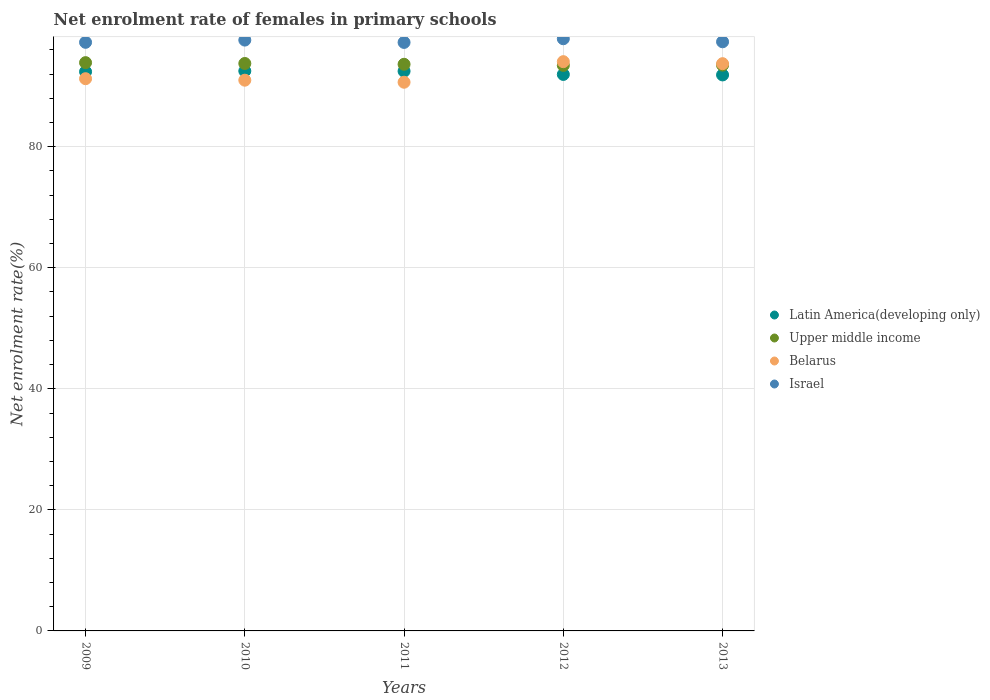How many different coloured dotlines are there?
Your response must be concise. 4. Is the number of dotlines equal to the number of legend labels?
Your answer should be compact. Yes. What is the net enrolment rate of females in primary schools in Israel in 2012?
Give a very brief answer. 97.83. Across all years, what is the maximum net enrolment rate of females in primary schools in Latin America(developing only)?
Your answer should be compact. 92.5. Across all years, what is the minimum net enrolment rate of females in primary schools in Latin America(developing only)?
Give a very brief answer. 91.85. In which year was the net enrolment rate of females in primary schools in Israel minimum?
Offer a terse response. 2011. What is the total net enrolment rate of females in primary schools in Israel in the graph?
Your answer should be very brief. 487.22. What is the difference between the net enrolment rate of females in primary schools in Upper middle income in 2012 and that in 2013?
Your response must be concise. -0.04. What is the difference between the net enrolment rate of females in primary schools in Upper middle income in 2011 and the net enrolment rate of females in primary schools in Israel in 2012?
Your answer should be very brief. -4.22. What is the average net enrolment rate of females in primary schools in Israel per year?
Provide a succinct answer. 97.44. In the year 2011, what is the difference between the net enrolment rate of females in primary schools in Upper middle income and net enrolment rate of females in primary schools in Israel?
Your response must be concise. -3.61. In how many years, is the net enrolment rate of females in primary schools in Upper middle income greater than 68 %?
Your response must be concise. 5. What is the ratio of the net enrolment rate of females in primary schools in Israel in 2012 to that in 2013?
Make the answer very short. 1.01. Is the difference between the net enrolment rate of females in primary schools in Upper middle income in 2009 and 2011 greater than the difference between the net enrolment rate of females in primary schools in Israel in 2009 and 2011?
Keep it short and to the point. Yes. What is the difference between the highest and the second highest net enrolment rate of females in primary schools in Belarus?
Give a very brief answer. 0.33. What is the difference between the highest and the lowest net enrolment rate of females in primary schools in Latin America(developing only)?
Provide a succinct answer. 0.65. In how many years, is the net enrolment rate of females in primary schools in Israel greater than the average net enrolment rate of females in primary schools in Israel taken over all years?
Ensure brevity in your answer.  2. Is it the case that in every year, the sum of the net enrolment rate of females in primary schools in Israel and net enrolment rate of females in primary schools in Belarus  is greater than the sum of net enrolment rate of females in primary schools in Latin America(developing only) and net enrolment rate of females in primary schools in Upper middle income?
Keep it short and to the point. No. Does the net enrolment rate of females in primary schools in Upper middle income monotonically increase over the years?
Keep it short and to the point. No. Is the net enrolment rate of females in primary schools in Upper middle income strictly greater than the net enrolment rate of females in primary schools in Israel over the years?
Ensure brevity in your answer.  No. How many dotlines are there?
Provide a short and direct response. 4. How many years are there in the graph?
Your answer should be very brief. 5. Are the values on the major ticks of Y-axis written in scientific E-notation?
Your answer should be very brief. No. Does the graph contain any zero values?
Ensure brevity in your answer.  No. Where does the legend appear in the graph?
Offer a terse response. Center right. How many legend labels are there?
Give a very brief answer. 4. What is the title of the graph?
Keep it short and to the point. Net enrolment rate of females in primary schools. Does "Latin America(developing only)" appear as one of the legend labels in the graph?
Your response must be concise. Yes. What is the label or title of the X-axis?
Provide a succinct answer. Years. What is the label or title of the Y-axis?
Offer a very short reply. Net enrolment rate(%). What is the Net enrolment rate(%) of Latin America(developing only) in 2009?
Your answer should be compact. 92.39. What is the Net enrolment rate(%) in Upper middle income in 2009?
Make the answer very short. 93.88. What is the Net enrolment rate(%) of Belarus in 2009?
Your response must be concise. 91.23. What is the Net enrolment rate(%) of Israel in 2009?
Provide a short and direct response. 97.24. What is the Net enrolment rate(%) of Latin America(developing only) in 2010?
Your response must be concise. 92.5. What is the Net enrolment rate(%) of Upper middle income in 2010?
Keep it short and to the point. 93.74. What is the Net enrolment rate(%) of Belarus in 2010?
Offer a terse response. 90.98. What is the Net enrolment rate(%) of Israel in 2010?
Your answer should be very brief. 97.61. What is the Net enrolment rate(%) in Latin America(developing only) in 2011?
Ensure brevity in your answer.  92.47. What is the Net enrolment rate(%) of Upper middle income in 2011?
Your response must be concise. 93.61. What is the Net enrolment rate(%) of Belarus in 2011?
Provide a short and direct response. 90.65. What is the Net enrolment rate(%) in Israel in 2011?
Your answer should be very brief. 97.22. What is the Net enrolment rate(%) in Latin America(developing only) in 2012?
Make the answer very short. 91.93. What is the Net enrolment rate(%) in Upper middle income in 2012?
Your answer should be very brief. 93.43. What is the Net enrolment rate(%) in Belarus in 2012?
Your response must be concise. 94.04. What is the Net enrolment rate(%) in Israel in 2012?
Make the answer very short. 97.83. What is the Net enrolment rate(%) in Latin America(developing only) in 2013?
Offer a terse response. 91.85. What is the Net enrolment rate(%) of Upper middle income in 2013?
Keep it short and to the point. 93.47. What is the Net enrolment rate(%) in Belarus in 2013?
Keep it short and to the point. 93.71. What is the Net enrolment rate(%) of Israel in 2013?
Provide a succinct answer. 97.33. Across all years, what is the maximum Net enrolment rate(%) of Latin America(developing only)?
Make the answer very short. 92.5. Across all years, what is the maximum Net enrolment rate(%) of Upper middle income?
Give a very brief answer. 93.88. Across all years, what is the maximum Net enrolment rate(%) in Belarus?
Offer a terse response. 94.04. Across all years, what is the maximum Net enrolment rate(%) in Israel?
Offer a very short reply. 97.83. Across all years, what is the minimum Net enrolment rate(%) of Latin America(developing only)?
Keep it short and to the point. 91.85. Across all years, what is the minimum Net enrolment rate(%) in Upper middle income?
Offer a very short reply. 93.43. Across all years, what is the minimum Net enrolment rate(%) of Belarus?
Give a very brief answer. 90.65. Across all years, what is the minimum Net enrolment rate(%) of Israel?
Provide a short and direct response. 97.22. What is the total Net enrolment rate(%) of Latin America(developing only) in the graph?
Offer a very short reply. 461.15. What is the total Net enrolment rate(%) in Upper middle income in the graph?
Your answer should be compact. 468.14. What is the total Net enrolment rate(%) of Belarus in the graph?
Your answer should be compact. 460.61. What is the total Net enrolment rate(%) in Israel in the graph?
Provide a short and direct response. 487.22. What is the difference between the Net enrolment rate(%) of Latin America(developing only) in 2009 and that in 2010?
Keep it short and to the point. -0.12. What is the difference between the Net enrolment rate(%) of Upper middle income in 2009 and that in 2010?
Keep it short and to the point. 0.14. What is the difference between the Net enrolment rate(%) in Belarus in 2009 and that in 2010?
Offer a very short reply. 0.25. What is the difference between the Net enrolment rate(%) of Israel in 2009 and that in 2010?
Give a very brief answer. -0.37. What is the difference between the Net enrolment rate(%) in Latin America(developing only) in 2009 and that in 2011?
Offer a very short reply. -0.09. What is the difference between the Net enrolment rate(%) in Upper middle income in 2009 and that in 2011?
Your answer should be very brief. 0.27. What is the difference between the Net enrolment rate(%) in Belarus in 2009 and that in 2011?
Ensure brevity in your answer.  0.58. What is the difference between the Net enrolment rate(%) of Israel in 2009 and that in 2011?
Offer a terse response. 0.02. What is the difference between the Net enrolment rate(%) in Latin America(developing only) in 2009 and that in 2012?
Make the answer very short. 0.45. What is the difference between the Net enrolment rate(%) of Upper middle income in 2009 and that in 2012?
Keep it short and to the point. 0.45. What is the difference between the Net enrolment rate(%) in Belarus in 2009 and that in 2012?
Your answer should be compact. -2.81. What is the difference between the Net enrolment rate(%) of Israel in 2009 and that in 2012?
Your answer should be very brief. -0.59. What is the difference between the Net enrolment rate(%) of Latin America(developing only) in 2009 and that in 2013?
Give a very brief answer. 0.53. What is the difference between the Net enrolment rate(%) in Upper middle income in 2009 and that in 2013?
Your answer should be compact. 0.41. What is the difference between the Net enrolment rate(%) of Belarus in 2009 and that in 2013?
Your answer should be very brief. -2.48. What is the difference between the Net enrolment rate(%) of Israel in 2009 and that in 2013?
Your answer should be compact. -0.09. What is the difference between the Net enrolment rate(%) in Latin America(developing only) in 2010 and that in 2011?
Ensure brevity in your answer.  0.03. What is the difference between the Net enrolment rate(%) in Upper middle income in 2010 and that in 2011?
Offer a very short reply. 0.13. What is the difference between the Net enrolment rate(%) in Belarus in 2010 and that in 2011?
Make the answer very short. 0.34. What is the difference between the Net enrolment rate(%) in Israel in 2010 and that in 2011?
Offer a very short reply. 0.39. What is the difference between the Net enrolment rate(%) of Latin America(developing only) in 2010 and that in 2012?
Give a very brief answer. 0.57. What is the difference between the Net enrolment rate(%) of Upper middle income in 2010 and that in 2012?
Offer a very short reply. 0.31. What is the difference between the Net enrolment rate(%) of Belarus in 2010 and that in 2012?
Make the answer very short. -3.06. What is the difference between the Net enrolment rate(%) in Israel in 2010 and that in 2012?
Provide a short and direct response. -0.22. What is the difference between the Net enrolment rate(%) of Latin America(developing only) in 2010 and that in 2013?
Make the answer very short. 0.65. What is the difference between the Net enrolment rate(%) of Upper middle income in 2010 and that in 2013?
Your answer should be compact. 0.27. What is the difference between the Net enrolment rate(%) in Belarus in 2010 and that in 2013?
Offer a very short reply. -2.73. What is the difference between the Net enrolment rate(%) in Israel in 2010 and that in 2013?
Make the answer very short. 0.28. What is the difference between the Net enrolment rate(%) of Latin America(developing only) in 2011 and that in 2012?
Your answer should be very brief. 0.54. What is the difference between the Net enrolment rate(%) of Upper middle income in 2011 and that in 2012?
Keep it short and to the point. 0.18. What is the difference between the Net enrolment rate(%) of Belarus in 2011 and that in 2012?
Keep it short and to the point. -3.4. What is the difference between the Net enrolment rate(%) in Israel in 2011 and that in 2012?
Give a very brief answer. -0.61. What is the difference between the Net enrolment rate(%) in Latin America(developing only) in 2011 and that in 2013?
Ensure brevity in your answer.  0.62. What is the difference between the Net enrolment rate(%) of Upper middle income in 2011 and that in 2013?
Ensure brevity in your answer.  0.14. What is the difference between the Net enrolment rate(%) in Belarus in 2011 and that in 2013?
Make the answer very short. -3.07. What is the difference between the Net enrolment rate(%) of Israel in 2011 and that in 2013?
Provide a short and direct response. -0.11. What is the difference between the Net enrolment rate(%) of Latin America(developing only) in 2012 and that in 2013?
Your response must be concise. 0.08. What is the difference between the Net enrolment rate(%) of Upper middle income in 2012 and that in 2013?
Keep it short and to the point. -0.04. What is the difference between the Net enrolment rate(%) of Belarus in 2012 and that in 2013?
Keep it short and to the point. 0.33. What is the difference between the Net enrolment rate(%) of Israel in 2012 and that in 2013?
Make the answer very short. 0.5. What is the difference between the Net enrolment rate(%) in Latin America(developing only) in 2009 and the Net enrolment rate(%) in Upper middle income in 2010?
Ensure brevity in your answer.  -1.36. What is the difference between the Net enrolment rate(%) in Latin America(developing only) in 2009 and the Net enrolment rate(%) in Belarus in 2010?
Ensure brevity in your answer.  1.4. What is the difference between the Net enrolment rate(%) in Latin America(developing only) in 2009 and the Net enrolment rate(%) in Israel in 2010?
Your response must be concise. -5.22. What is the difference between the Net enrolment rate(%) in Upper middle income in 2009 and the Net enrolment rate(%) in Belarus in 2010?
Offer a very short reply. 2.9. What is the difference between the Net enrolment rate(%) in Upper middle income in 2009 and the Net enrolment rate(%) in Israel in 2010?
Offer a very short reply. -3.73. What is the difference between the Net enrolment rate(%) of Belarus in 2009 and the Net enrolment rate(%) of Israel in 2010?
Provide a short and direct response. -6.38. What is the difference between the Net enrolment rate(%) in Latin America(developing only) in 2009 and the Net enrolment rate(%) in Upper middle income in 2011?
Make the answer very short. -1.22. What is the difference between the Net enrolment rate(%) of Latin America(developing only) in 2009 and the Net enrolment rate(%) of Belarus in 2011?
Your response must be concise. 1.74. What is the difference between the Net enrolment rate(%) in Latin America(developing only) in 2009 and the Net enrolment rate(%) in Israel in 2011?
Provide a short and direct response. -4.84. What is the difference between the Net enrolment rate(%) of Upper middle income in 2009 and the Net enrolment rate(%) of Belarus in 2011?
Make the answer very short. 3.24. What is the difference between the Net enrolment rate(%) of Upper middle income in 2009 and the Net enrolment rate(%) of Israel in 2011?
Your response must be concise. -3.34. What is the difference between the Net enrolment rate(%) of Belarus in 2009 and the Net enrolment rate(%) of Israel in 2011?
Give a very brief answer. -5.99. What is the difference between the Net enrolment rate(%) in Latin America(developing only) in 2009 and the Net enrolment rate(%) in Upper middle income in 2012?
Give a very brief answer. -1.05. What is the difference between the Net enrolment rate(%) in Latin America(developing only) in 2009 and the Net enrolment rate(%) in Belarus in 2012?
Ensure brevity in your answer.  -1.66. What is the difference between the Net enrolment rate(%) in Latin America(developing only) in 2009 and the Net enrolment rate(%) in Israel in 2012?
Offer a very short reply. -5.44. What is the difference between the Net enrolment rate(%) in Upper middle income in 2009 and the Net enrolment rate(%) in Belarus in 2012?
Offer a terse response. -0.16. What is the difference between the Net enrolment rate(%) in Upper middle income in 2009 and the Net enrolment rate(%) in Israel in 2012?
Your response must be concise. -3.95. What is the difference between the Net enrolment rate(%) in Belarus in 2009 and the Net enrolment rate(%) in Israel in 2012?
Provide a short and direct response. -6.6. What is the difference between the Net enrolment rate(%) of Latin America(developing only) in 2009 and the Net enrolment rate(%) of Upper middle income in 2013?
Your answer should be compact. -1.09. What is the difference between the Net enrolment rate(%) in Latin America(developing only) in 2009 and the Net enrolment rate(%) in Belarus in 2013?
Make the answer very short. -1.33. What is the difference between the Net enrolment rate(%) in Latin America(developing only) in 2009 and the Net enrolment rate(%) in Israel in 2013?
Provide a short and direct response. -4.94. What is the difference between the Net enrolment rate(%) in Upper middle income in 2009 and the Net enrolment rate(%) in Belarus in 2013?
Keep it short and to the point. 0.17. What is the difference between the Net enrolment rate(%) in Upper middle income in 2009 and the Net enrolment rate(%) in Israel in 2013?
Give a very brief answer. -3.45. What is the difference between the Net enrolment rate(%) of Belarus in 2009 and the Net enrolment rate(%) of Israel in 2013?
Provide a succinct answer. -6.1. What is the difference between the Net enrolment rate(%) of Latin America(developing only) in 2010 and the Net enrolment rate(%) of Upper middle income in 2011?
Ensure brevity in your answer.  -1.11. What is the difference between the Net enrolment rate(%) in Latin America(developing only) in 2010 and the Net enrolment rate(%) in Belarus in 2011?
Provide a succinct answer. 1.86. What is the difference between the Net enrolment rate(%) of Latin America(developing only) in 2010 and the Net enrolment rate(%) of Israel in 2011?
Give a very brief answer. -4.72. What is the difference between the Net enrolment rate(%) in Upper middle income in 2010 and the Net enrolment rate(%) in Belarus in 2011?
Provide a succinct answer. 3.1. What is the difference between the Net enrolment rate(%) in Upper middle income in 2010 and the Net enrolment rate(%) in Israel in 2011?
Provide a succinct answer. -3.48. What is the difference between the Net enrolment rate(%) in Belarus in 2010 and the Net enrolment rate(%) in Israel in 2011?
Ensure brevity in your answer.  -6.24. What is the difference between the Net enrolment rate(%) of Latin America(developing only) in 2010 and the Net enrolment rate(%) of Upper middle income in 2012?
Your answer should be very brief. -0.93. What is the difference between the Net enrolment rate(%) in Latin America(developing only) in 2010 and the Net enrolment rate(%) in Belarus in 2012?
Provide a short and direct response. -1.54. What is the difference between the Net enrolment rate(%) in Latin America(developing only) in 2010 and the Net enrolment rate(%) in Israel in 2012?
Keep it short and to the point. -5.33. What is the difference between the Net enrolment rate(%) in Upper middle income in 2010 and the Net enrolment rate(%) in Belarus in 2012?
Give a very brief answer. -0.3. What is the difference between the Net enrolment rate(%) in Upper middle income in 2010 and the Net enrolment rate(%) in Israel in 2012?
Offer a very short reply. -4.09. What is the difference between the Net enrolment rate(%) in Belarus in 2010 and the Net enrolment rate(%) in Israel in 2012?
Provide a succinct answer. -6.85. What is the difference between the Net enrolment rate(%) in Latin America(developing only) in 2010 and the Net enrolment rate(%) in Upper middle income in 2013?
Provide a succinct answer. -0.97. What is the difference between the Net enrolment rate(%) in Latin America(developing only) in 2010 and the Net enrolment rate(%) in Belarus in 2013?
Your answer should be very brief. -1.21. What is the difference between the Net enrolment rate(%) in Latin America(developing only) in 2010 and the Net enrolment rate(%) in Israel in 2013?
Ensure brevity in your answer.  -4.83. What is the difference between the Net enrolment rate(%) of Upper middle income in 2010 and the Net enrolment rate(%) of Belarus in 2013?
Your answer should be very brief. 0.03. What is the difference between the Net enrolment rate(%) of Upper middle income in 2010 and the Net enrolment rate(%) of Israel in 2013?
Provide a succinct answer. -3.58. What is the difference between the Net enrolment rate(%) of Belarus in 2010 and the Net enrolment rate(%) of Israel in 2013?
Provide a succinct answer. -6.34. What is the difference between the Net enrolment rate(%) in Latin America(developing only) in 2011 and the Net enrolment rate(%) in Upper middle income in 2012?
Keep it short and to the point. -0.96. What is the difference between the Net enrolment rate(%) of Latin America(developing only) in 2011 and the Net enrolment rate(%) of Belarus in 2012?
Provide a succinct answer. -1.57. What is the difference between the Net enrolment rate(%) of Latin America(developing only) in 2011 and the Net enrolment rate(%) of Israel in 2012?
Keep it short and to the point. -5.36. What is the difference between the Net enrolment rate(%) of Upper middle income in 2011 and the Net enrolment rate(%) of Belarus in 2012?
Make the answer very short. -0.43. What is the difference between the Net enrolment rate(%) in Upper middle income in 2011 and the Net enrolment rate(%) in Israel in 2012?
Make the answer very short. -4.22. What is the difference between the Net enrolment rate(%) of Belarus in 2011 and the Net enrolment rate(%) of Israel in 2012?
Your answer should be very brief. -7.18. What is the difference between the Net enrolment rate(%) of Latin America(developing only) in 2011 and the Net enrolment rate(%) of Upper middle income in 2013?
Offer a terse response. -1. What is the difference between the Net enrolment rate(%) of Latin America(developing only) in 2011 and the Net enrolment rate(%) of Belarus in 2013?
Ensure brevity in your answer.  -1.24. What is the difference between the Net enrolment rate(%) of Latin America(developing only) in 2011 and the Net enrolment rate(%) of Israel in 2013?
Make the answer very short. -4.85. What is the difference between the Net enrolment rate(%) of Upper middle income in 2011 and the Net enrolment rate(%) of Belarus in 2013?
Provide a short and direct response. -0.1. What is the difference between the Net enrolment rate(%) in Upper middle income in 2011 and the Net enrolment rate(%) in Israel in 2013?
Your answer should be very brief. -3.72. What is the difference between the Net enrolment rate(%) of Belarus in 2011 and the Net enrolment rate(%) of Israel in 2013?
Your response must be concise. -6.68. What is the difference between the Net enrolment rate(%) of Latin America(developing only) in 2012 and the Net enrolment rate(%) of Upper middle income in 2013?
Offer a terse response. -1.54. What is the difference between the Net enrolment rate(%) of Latin America(developing only) in 2012 and the Net enrolment rate(%) of Belarus in 2013?
Your answer should be compact. -1.78. What is the difference between the Net enrolment rate(%) in Latin America(developing only) in 2012 and the Net enrolment rate(%) in Israel in 2013?
Make the answer very short. -5.39. What is the difference between the Net enrolment rate(%) of Upper middle income in 2012 and the Net enrolment rate(%) of Belarus in 2013?
Your answer should be compact. -0.28. What is the difference between the Net enrolment rate(%) in Upper middle income in 2012 and the Net enrolment rate(%) in Israel in 2013?
Your answer should be very brief. -3.9. What is the difference between the Net enrolment rate(%) of Belarus in 2012 and the Net enrolment rate(%) of Israel in 2013?
Provide a succinct answer. -3.28. What is the average Net enrolment rate(%) in Latin America(developing only) per year?
Give a very brief answer. 92.23. What is the average Net enrolment rate(%) of Upper middle income per year?
Your response must be concise. 93.63. What is the average Net enrolment rate(%) in Belarus per year?
Offer a terse response. 92.12. What is the average Net enrolment rate(%) in Israel per year?
Offer a terse response. 97.44. In the year 2009, what is the difference between the Net enrolment rate(%) in Latin America(developing only) and Net enrolment rate(%) in Upper middle income?
Keep it short and to the point. -1.5. In the year 2009, what is the difference between the Net enrolment rate(%) of Latin America(developing only) and Net enrolment rate(%) of Belarus?
Your answer should be very brief. 1.16. In the year 2009, what is the difference between the Net enrolment rate(%) in Latin America(developing only) and Net enrolment rate(%) in Israel?
Give a very brief answer. -4.85. In the year 2009, what is the difference between the Net enrolment rate(%) in Upper middle income and Net enrolment rate(%) in Belarus?
Give a very brief answer. 2.65. In the year 2009, what is the difference between the Net enrolment rate(%) of Upper middle income and Net enrolment rate(%) of Israel?
Your answer should be compact. -3.36. In the year 2009, what is the difference between the Net enrolment rate(%) in Belarus and Net enrolment rate(%) in Israel?
Provide a short and direct response. -6.01. In the year 2010, what is the difference between the Net enrolment rate(%) in Latin America(developing only) and Net enrolment rate(%) in Upper middle income?
Provide a succinct answer. -1.24. In the year 2010, what is the difference between the Net enrolment rate(%) in Latin America(developing only) and Net enrolment rate(%) in Belarus?
Provide a short and direct response. 1.52. In the year 2010, what is the difference between the Net enrolment rate(%) in Latin America(developing only) and Net enrolment rate(%) in Israel?
Ensure brevity in your answer.  -5.11. In the year 2010, what is the difference between the Net enrolment rate(%) of Upper middle income and Net enrolment rate(%) of Belarus?
Keep it short and to the point. 2.76. In the year 2010, what is the difference between the Net enrolment rate(%) in Upper middle income and Net enrolment rate(%) in Israel?
Provide a succinct answer. -3.86. In the year 2010, what is the difference between the Net enrolment rate(%) in Belarus and Net enrolment rate(%) in Israel?
Provide a succinct answer. -6.62. In the year 2011, what is the difference between the Net enrolment rate(%) of Latin America(developing only) and Net enrolment rate(%) of Upper middle income?
Offer a very short reply. -1.14. In the year 2011, what is the difference between the Net enrolment rate(%) in Latin America(developing only) and Net enrolment rate(%) in Belarus?
Ensure brevity in your answer.  1.83. In the year 2011, what is the difference between the Net enrolment rate(%) of Latin America(developing only) and Net enrolment rate(%) of Israel?
Make the answer very short. -4.75. In the year 2011, what is the difference between the Net enrolment rate(%) in Upper middle income and Net enrolment rate(%) in Belarus?
Offer a very short reply. 2.96. In the year 2011, what is the difference between the Net enrolment rate(%) in Upper middle income and Net enrolment rate(%) in Israel?
Make the answer very short. -3.61. In the year 2011, what is the difference between the Net enrolment rate(%) in Belarus and Net enrolment rate(%) in Israel?
Your answer should be compact. -6.58. In the year 2012, what is the difference between the Net enrolment rate(%) of Latin America(developing only) and Net enrolment rate(%) of Upper middle income?
Give a very brief answer. -1.5. In the year 2012, what is the difference between the Net enrolment rate(%) in Latin America(developing only) and Net enrolment rate(%) in Belarus?
Make the answer very short. -2.11. In the year 2012, what is the difference between the Net enrolment rate(%) in Latin America(developing only) and Net enrolment rate(%) in Israel?
Your response must be concise. -5.9. In the year 2012, what is the difference between the Net enrolment rate(%) in Upper middle income and Net enrolment rate(%) in Belarus?
Offer a terse response. -0.61. In the year 2012, what is the difference between the Net enrolment rate(%) of Upper middle income and Net enrolment rate(%) of Israel?
Give a very brief answer. -4.4. In the year 2012, what is the difference between the Net enrolment rate(%) of Belarus and Net enrolment rate(%) of Israel?
Keep it short and to the point. -3.79. In the year 2013, what is the difference between the Net enrolment rate(%) in Latin America(developing only) and Net enrolment rate(%) in Upper middle income?
Keep it short and to the point. -1.62. In the year 2013, what is the difference between the Net enrolment rate(%) of Latin America(developing only) and Net enrolment rate(%) of Belarus?
Provide a succinct answer. -1.86. In the year 2013, what is the difference between the Net enrolment rate(%) in Latin America(developing only) and Net enrolment rate(%) in Israel?
Make the answer very short. -5.48. In the year 2013, what is the difference between the Net enrolment rate(%) of Upper middle income and Net enrolment rate(%) of Belarus?
Your response must be concise. -0.24. In the year 2013, what is the difference between the Net enrolment rate(%) in Upper middle income and Net enrolment rate(%) in Israel?
Give a very brief answer. -3.85. In the year 2013, what is the difference between the Net enrolment rate(%) of Belarus and Net enrolment rate(%) of Israel?
Ensure brevity in your answer.  -3.62. What is the ratio of the Net enrolment rate(%) of Upper middle income in 2009 to that in 2010?
Provide a succinct answer. 1. What is the ratio of the Net enrolment rate(%) in Upper middle income in 2009 to that in 2011?
Ensure brevity in your answer.  1. What is the ratio of the Net enrolment rate(%) of Belarus in 2009 to that in 2011?
Offer a very short reply. 1.01. What is the ratio of the Net enrolment rate(%) in Upper middle income in 2009 to that in 2012?
Your answer should be very brief. 1. What is the ratio of the Net enrolment rate(%) of Belarus in 2009 to that in 2012?
Offer a terse response. 0.97. What is the ratio of the Net enrolment rate(%) in Israel in 2009 to that in 2012?
Provide a short and direct response. 0.99. What is the ratio of the Net enrolment rate(%) in Latin America(developing only) in 2009 to that in 2013?
Provide a succinct answer. 1.01. What is the ratio of the Net enrolment rate(%) in Belarus in 2009 to that in 2013?
Give a very brief answer. 0.97. What is the ratio of the Net enrolment rate(%) in Belarus in 2010 to that in 2011?
Provide a short and direct response. 1. What is the ratio of the Net enrolment rate(%) in Latin America(developing only) in 2010 to that in 2012?
Give a very brief answer. 1.01. What is the ratio of the Net enrolment rate(%) in Belarus in 2010 to that in 2012?
Give a very brief answer. 0.97. What is the ratio of the Net enrolment rate(%) in Latin America(developing only) in 2010 to that in 2013?
Your answer should be compact. 1.01. What is the ratio of the Net enrolment rate(%) in Belarus in 2010 to that in 2013?
Your response must be concise. 0.97. What is the ratio of the Net enrolment rate(%) in Israel in 2010 to that in 2013?
Make the answer very short. 1. What is the ratio of the Net enrolment rate(%) of Latin America(developing only) in 2011 to that in 2012?
Your answer should be compact. 1.01. What is the ratio of the Net enrolment rate(%) of Belarus in 2011 to that in 2012?
Offer a terse response. 0.96. What is the ratio of the Net enrolment rate(%) of Latin America(developing only) in 2011 to that in 2013?
Give a very brief answer. 1.01. What is the ratio of the Net enrolment rate(%) of Upper middle income in 2011 to that in 2013?
Ensure brevity in your answer.  1. What is the ratio of the Net enrolment rate(%) of Belarus in 2011 to that in 2013?
Your response must be concise. 0.97. What is the ratio of the Net enrolment rate(%) of Israel in 2011 to that in 2013?
Give a very brief answer. 1. What is the ratio of the Net enrolment rate(%) in Upper middle income in 2012 to that in 2013?
Provide a succinct answer. 1. What is the ratio of the Net enrolment rate(%) in Israel in 2012 to that in 2013?
Offer a very short reply. 1.01. What is the difference between the highest and the second highest Net enrolment rate(%) in Latin America(developing only)?
Make the answer very short. 0.03. What is the difference between the highest and the second highest Net enrolment rate(%) in Upper middle income?
Offer a very short reply. 0.14. What is the difference between the highest and the second highest Net enrolment rate(%) in Belarus?
Give a very brief answer. 0.33. What is the difference between the highest and the second highest Net enrolment rate(%) of Israel?
Your response must be concise. 0.22. What is the difference between the highest and the lowest Net enrolment rate(%) of Latin America(developing only)?
Your answer should be compact. 0.65. What is the difference between the highest and the lowest Net enrolment rate(%) in Upper middle income?
Give a very brief answer. 0.45. What is the difference between the highest and the lowest Net enrolment rate(%) in Belarus?
Ensure brevity in your answer.  3.4. What is the difference between the highest and the lowest Net enrolment rate(%) of Israel?
Make the answer very short. 0.61. 